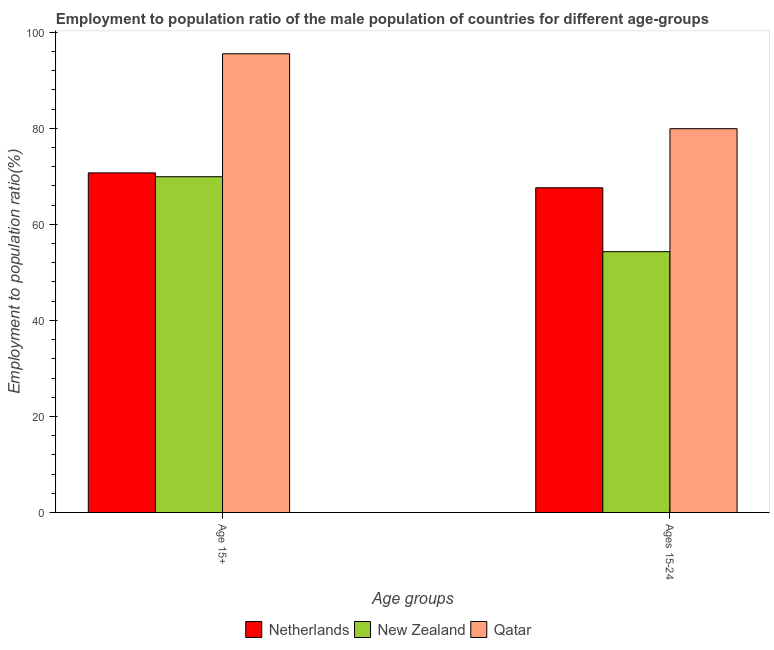How many groups of bars are there?
Provide a succinct answer. 2. How many bars are there on the 1st tick from the right?
Your response must be concise. 3. What is the label of the 2nd group of bars from the left?
Your answer should be compact. Ages 15-24. What is the employment to population ratio(age 15+) in New Zealand?
Make the answer very short. 69.9. Across all countries, what is the maximum employment to population ratio(age 15+)?
Provide a short and direct response. 95.5. Across all countries, what is the minimum employment to population ratio(age 15-24)?
Ensure brevity in your answer.  54.3. In which country was the employment to population ratio(age 15+) maximum?
Provide a succinct answer. Qatar. In which country was the employment to population ratio(age 15+) minimum?
Offer a terse response. New Zealand. What is the total employment to population ratio(age 15+) in the graph?
Provide a succinct answer. 236.1. What is the difference between the employment to population ratio(age 15-24) in Qatar and that in New Zealand?
Offer a very short reply. 25.6. What is the difference between the employment to population ratio(age 15-24) in Qatar and the employment to population ratio(age 15+) in New Zealand?
Your answer should be compact. 10. What is the average employment to population ratio(age 15+) per country?
Offer a terse response. 78.7. What is the difference between the employment to population ratio(age 15-24) and employment to population ratio(age 15+) in Qatar?
Offer a very short reply. -15.6. In how many countries, is the employment to population ratio(age 15+) greater than 32 %?
Your response must be concise. 3. What is the ratio of the employment to population ratio(age 15-24) in Netherlands to that in Qatar?
Your answer should be compact. 0.85. Is the employment to population ratio(age 15-24) in Netherlands less than that in Qatar?
Your response must be concise. Yes. What does the 1st bar from the left in Ages 15-24 represents?
Keep it short and to the point. Netherlands. What does the 1st bar from the right in Ages 15-24 represents?
Give a very brief answer. Qatar. How many countries are there in the graph?
Ensure brevity in your answer.  3. What is the difference between two consecutive major ticks on the Y-axis?
Offer a terse response. 20. Does the graph contain grids?
Provide a short and direct response. No. Where does the legend appear in the graph?
Provide a short and direct response. Bottom center. What is the title of the graph?
Make the answer very short. Employment to population ratio of the male population of countries for different age-groups. What is the label or title of the X-axis?
Offer a terse response. Age groups. What is the Employment to population ratio(%) in Netherlands in Age 15+?
Provide a short and direct response. 70.7. What is the Employment to population ratio(%) in New Zealand in Age 15+?
Make the answer very short. 69.9. What is the Employment to population ratio(%) in Qatar in Age 15+?
Provide a short and direct response. 95.5. What is the Employment to population ratio(%) in Netherlands in Ages 15-24?
Keep it short and to the point. 67.6. What is the Employment to population ratio(%) of New Zealand in Ages 15-24?
Offer a terse response. 54.3. What is the Employment to population ratio(%) in Qatar in Ages 15-24?
Ensure brevity in your answer.  79.9. Across all Age groups, what is the maximum Employment to population ratio(%) in Netherlands?
Ensure brevity in your answer.  70.7. Across all Age groups, what is the maximum Employment to population ratio(%) in New Zealand?
Make the answer very short. 69.9. Across all Age groups, what is the maximum Employment to population ratio(%) of Qatar?
Make the answer very short. 95.5. Across all Age groups, what is the minimum Employment to population ratio(%) of Netherlands?
Give a very brief answer. 67.6. Across all Age groups, what is the minimum Employment to population ratio(%) of New Zealand?
Make the answer very short. 54.3. Across all Age groups, what is the minimum Employment to population ratio(%) in Qatar?
Provide a short and direct response. 79.9. What is the total Employment to population ratio(%) in Netherlands in the graph?
Keep it short and to the point. 138.3. What is the total Employment to population ratio(%) in New Zealand in the graph?
Ensure brevity in your answer.  124.2. What is the total Employment to population ratio(%) of Qatar in the graph?
Make the answer very short. 175.4. What is the difference between the Employment to population ratio(%) in Netherlands in Age 15+ and that in Ages 15-24?
Provide a short and direct response. 3.1. What is the difference between the Employment to population ratio(%) of Qatar in Age 15+ and that in Ages 15-24?
Ensure brevity in your answer.  15.6. What is the average Employment to population ratio(%) of Netherlands per Age groups?
Offer a very short reply. 69.15. What is the average Employment to population ratio(%) in New Zealand per Age groups?
Offer a terse response. 62.1. What is the average Employment to population ratio(%) of Qatar per Age groups?
Provide a succinct answer. 87.7. What is the difference between the Employment to population ratio(%) of Netherlands and Employment to population ratio(%) of New Zealand in Age 15+?
Make the answer very short. 0.8. What is the difference between the Employment to population ratio(%) of Netherlands and Employment to population ratio(%) of Qatar in Age 15+?
Offer a very short reply. -24.8. What is the difference between the Employment to population ratio(%) in New Zealand and Employment to population ratio(%) in Qatar in Age 15+?
Your answer should be compact. -25.6. What is the difference between the Employment to population ratio(%) of Netherlands and Employment to population ratio(%) of Qatar in Ages 15-24?
Keep it short and to the point. -12.3. What is the difference between the Employment to population ratio(%) of New Zealand and Employment to population ratio(%) of Qatar in Ages 15-24?
Offer a very short reply. -25.6. What is the ratio of the Employment to population ratio(%) of Netherlands in Age 15+ to that in Ages 15-24?
Give a very brief answer. 1.05. What is the ratio of the Employment to population ratio(%) in New Zealand in Age 15+ to that in Ages 15-24?
Your answer should be compact. 1.29. What is the ratio of the Employment to population ratio(%) in Qatar in Age 15+ to that in Ages 15-24?
Make the answer very short. 1.2. What is the difference between the highest and the lowest Employment to population ratio(%) of Netherlands?
Provide a succinct answer. 3.1. What is the difference between the highest and the lowest Employment to population ratio(%) of New Zealand?
Keep it short and to the point. 15.6. What is the difference between the highest and the lowest Employment to population ratio(%) of Qatar?
Offer a very short reply. 15.6. 